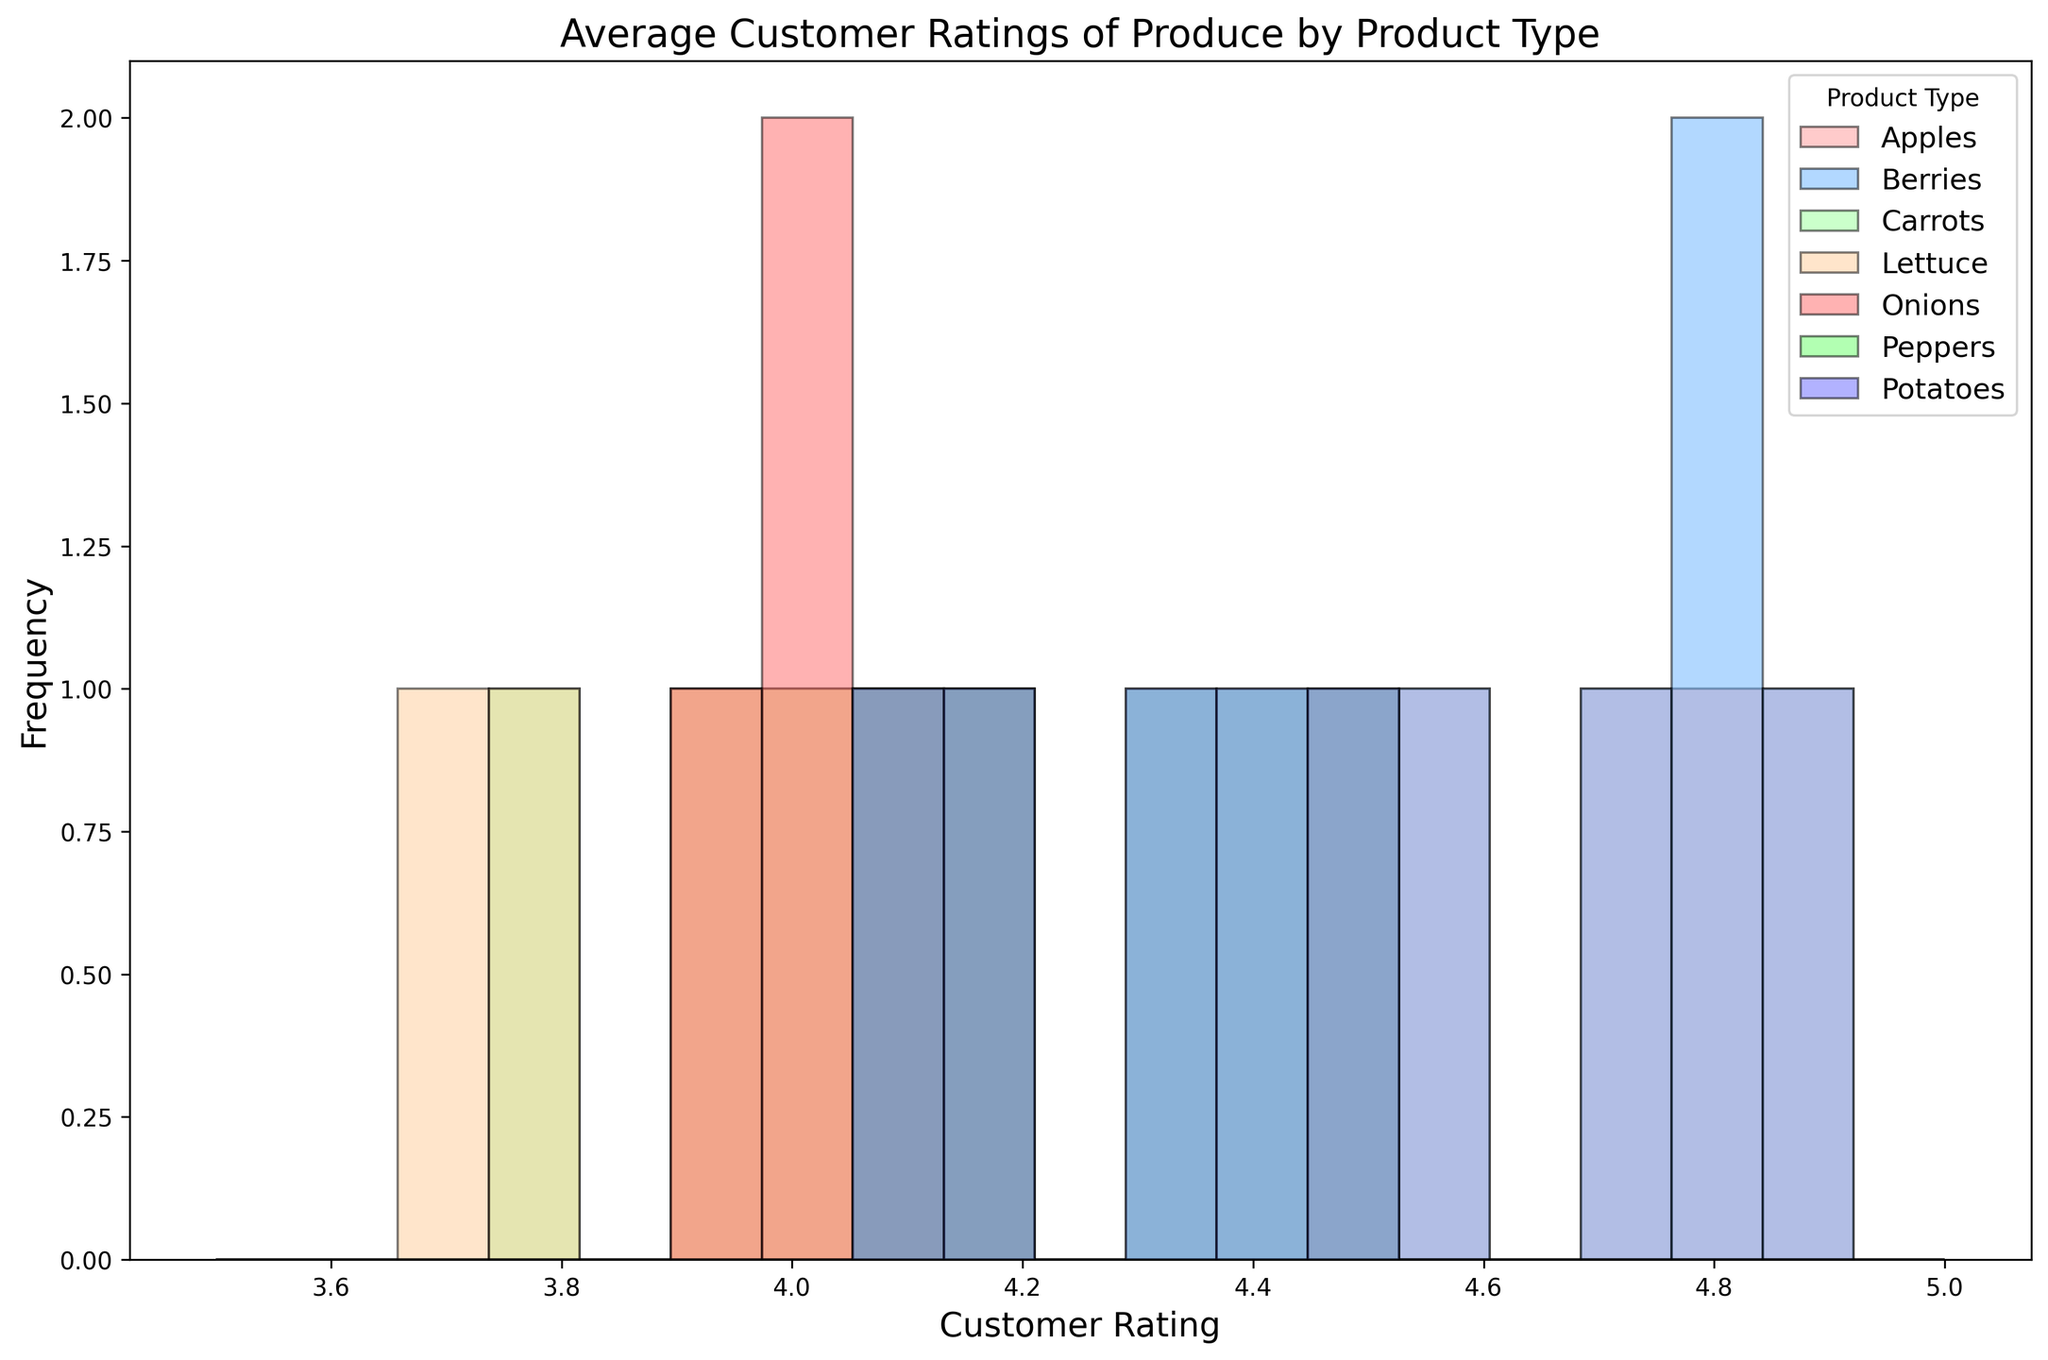How many different product types are compared in the histogram? To find the number of product types, look at the legend where each product type is listed. Count the different labels present.
Answer: 7 Which product type has the highest customer ratings on average? Inspect the histogram bars to identify the product type which has most of its ratings clustered towards the higher end (closer to 5.0).
Answer: Berries What is the range of customer ratings for Lettuce? Check the histogram bars for Lettuce (likely labeled in the legend) and note the minimum and maximum rating values displayed by Lettuce.
Answer: 3.7 to 4.1 Which product has a wider distribution of ratings, Apples or Carrots? Compare the width of the ranges covered by the histogram bars for Apples and Carrots. Wider range means a wider distribution.
Answer: Apples Is there any product type with all ratings above 4.0? Look at the histogram bars for each product type and check if all the bars are for ratings above 4.0.
Answer: Berries Which product type appears to have the most consistent (narrow range) customer ratings? Identify the product type whose histogram bars are closely packed together without much spread.
Answer: Onions What is the most frequent rating for Tomatoes? Identify the tallest histogram bar for Tomatoes and note the customer rating on the x-axis corresponding to this bar.
Answer: 4.2 Are the customer ratings for Peppers generally higher than those for Carrots? Compare the position of most bars for Peppers with that of Carrots. Higher ratings will be towards the right on the x-axis.
Answer: Yes Between Apples and Potatoes, which has more ratings in the 4.5 to 4.9 range? Look at the histogram bars for Apples and Potatoes in the 4.5 to 4.9 range and compare their heights.
Answer: Apples Which product types have at least one rating of 3.9? Look at the histogram for ratings marked at 3.9 and identify the product types from the legend.
Answer: Carrots, Lettuce, Onions 